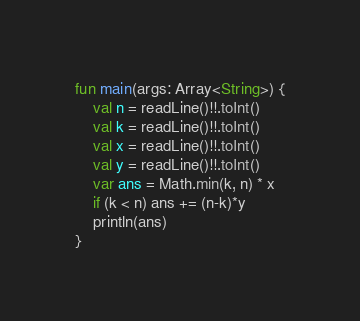<code> <loc_0><loc_0><loc_500><loc_500><_Kotlin_>fun main(args: Array<String>) {
    val n = readLine()!!.toInt()
    val k = readLine()!!.toInt()
    val x = readLine()!!.toInt()
    val y = readLine()!!.toInt()
    var ans = Math.min(k, n) * x
    if (k < n) ans += (n-k)*y
    println(ans)
}

</code> 